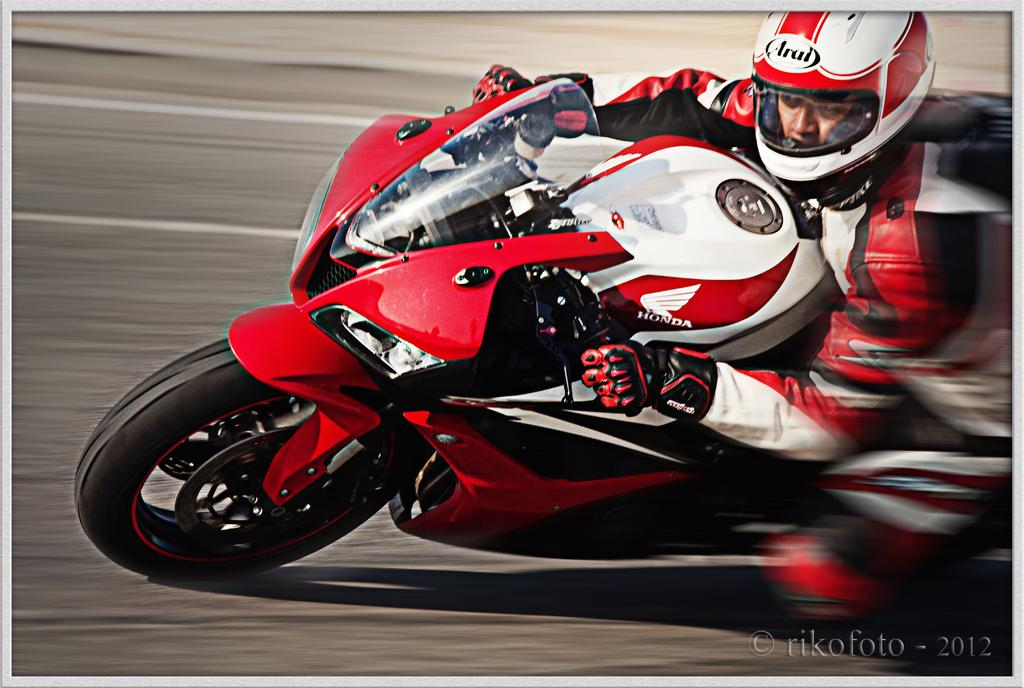Who is the main subject in the image? There is a man in the image. What is the man doing in the image? The man is riding a bike. Can you describe the color of the bike? The bike is red in color. What can be seen in the background of the image? There is a road visible in the background of the image. How many pigs are comfortably sitting on the man's shoulders in the image? There are no pigs present in the image, and therefore, none are sitting on the man's shoulders. 